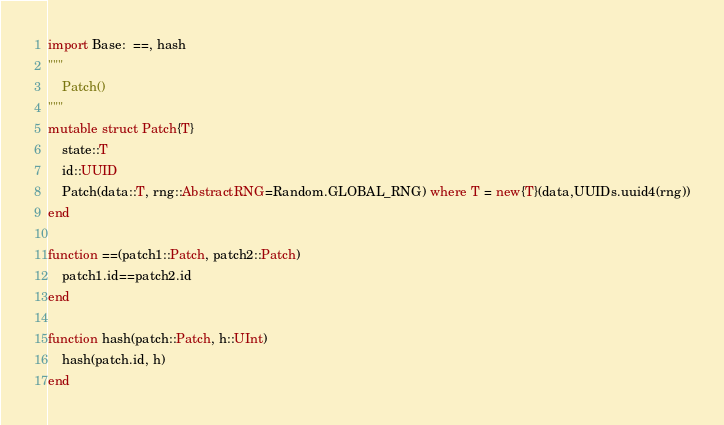<code> <loc_0><loc_0><loc_500><loc_500><_Julia_>import Base:  ==, hash
"""
    Patch()
"""
mutable struct Patch{T}
    state::T
    id::UUID
    Patch(data::T, rng::AbstractRNG=Random.GLOBAL_RNG) where T = new{T}(data,UUIDs.uuid4(rng))
end

function ==(patch1::Patch, patch2::Patch)
    patch1.id==patch2.id
end

function hash(patch::Patch, h::UInt)
    hash(patch.id, h)
end
</code> 